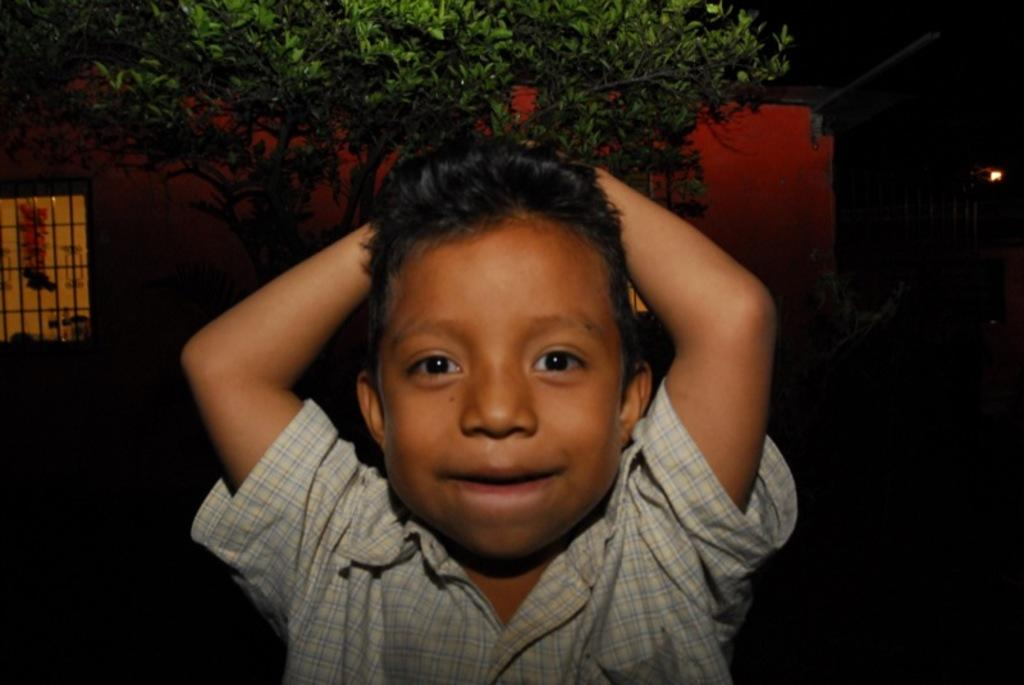What is the main subject of the image? There is a person standing in the image. What is the person wearing? The person is wearing a white shirt. What type of vegetation can be seen in the image? There are trees visible in the image. What is the color of the trees? The trees are green in color. What architectural feature is present in the image? There is a window in the image. What type of button can be seen on the machine in the image? There is no machine or button present in the image. Can you describe the deer grazing in the background of the image? There is no deer present in the image; it features a person, trees, and a window. 